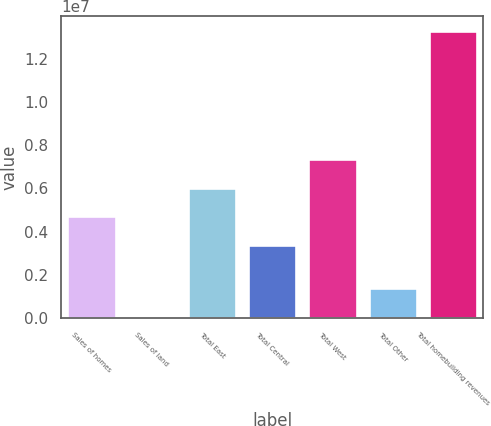<chart> <loc_0><loc_0><loc_500><loc_500><bar_chart><fcel>Sales of homes<fcel>Sales of land<fcel>Total East<fcel>Total Central<fcel>Total West<fcel>Total Other<fcel>Total homebuilding revenues<nl><fcel>4.69854e+06<fcel>68080<fcel>6.0222e+06<fcel>3.37489e+06<fcel>7.34585e+06<fcel>1.39173e+06<fcel>1.33046e+07<nl></chart> 